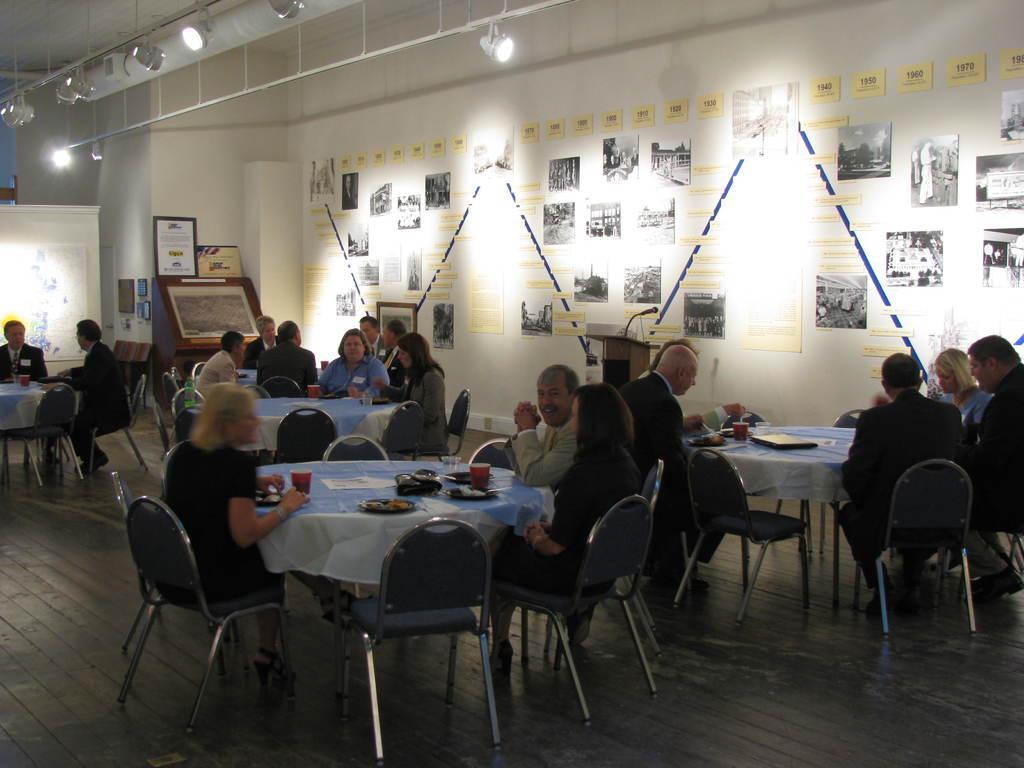In one or two sentences, can you explain what this image depicts? In this image i can see a group of people who are sitting on a chair in front of the table on the floor. On the table we have food, glasses, plates and other objects on it. We have a white color wall and lights over here. 